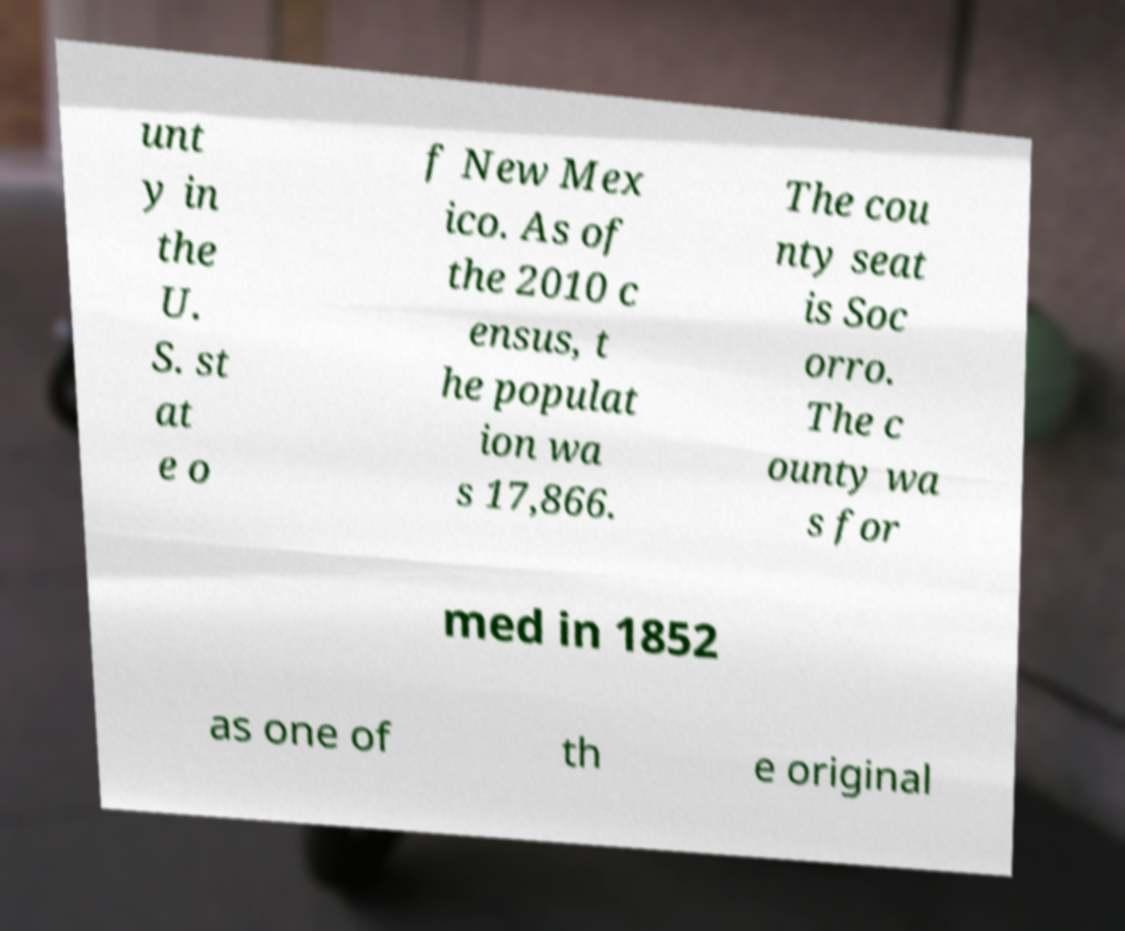For documentation purposes, I need the text within this image transcribed. Could you provide that? unt y in the U. S. st at e o f New Mex ico. As of the 2010 c ensus, t he populat ion wa s 17,866. The cou nty seat is Soc orro. The c ounty wa s for med in 1852 as one of th e original 